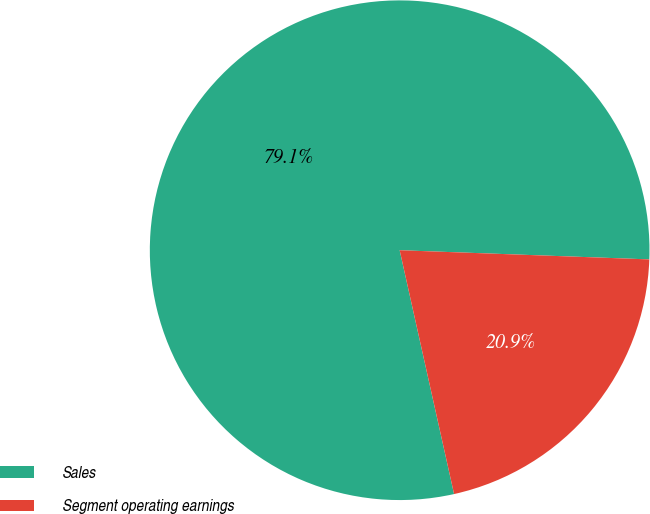<chart> <loc_0><loc_0><loc_500><loc_500><pie_chart><fcel>Sales<fcel>Segment operating earnings<nl><fcel>79.08%<fcel>20.92%<nl></chart> 